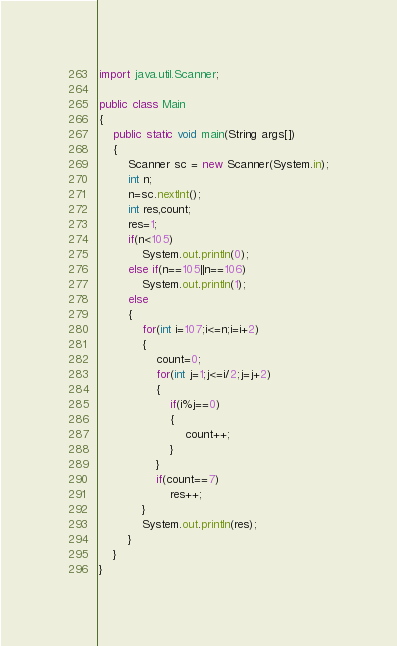<code> <loc_0><loc_0><loc_500><loc_500><_Java_>import java.util.Scanner;

public class Main 
{
	public static void main(String args[])
	{
		Scanner sc = new Scanner(System.in);
		int n;
		n=sc.nextInt();
		int res,count;
		res=1;
		if(n<105)
			System.out.println(0);
		else if(n==105||n==106)
			System.out.println(1);
		else
		{
			for(int i=107;i<=n;i=i+2)
			{
				count=0;
				for(int j=1;j<=i/2;j=j+2)
				{
					if(i%j==0)
					{
						count++;
					}
				}
				if(count==7)
					res++;
			}
			System.out.println(res);
		}		
	}
}
</code> 